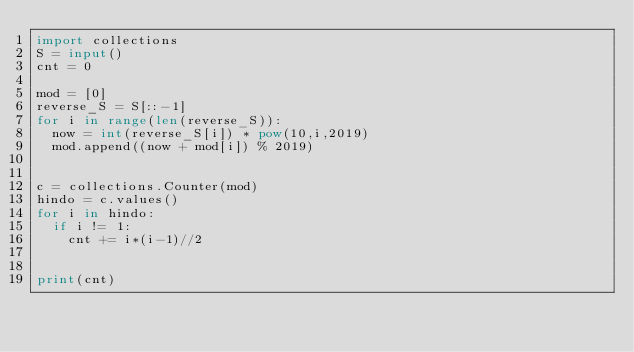Convert code to text. <code><loc_0><loc_0><loc_500><loc_500><_Python_>import collections
S = input()
cnt = 0

mod = [0]
reverse_S = S[::-1]
for i in range(len(reverse_S)):
  now = int(reverse_S[i]) * pow(10,i,2019)
  mod.append((now + mod[i]) % 2019)


c = collections.Counter(mod)
hindo = c.values()
for i in hindo:
  if i != 1:
    cnt += i*(i-1)//2


print(cnt)</code> 